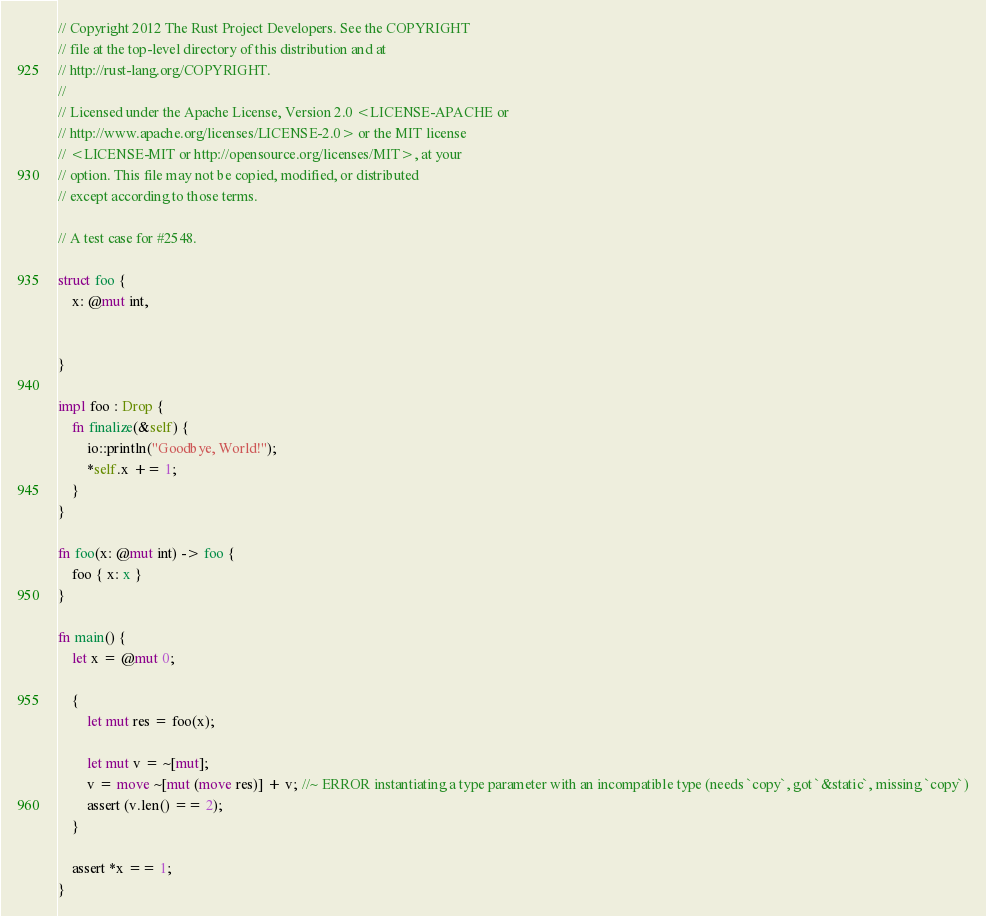<code> <loc_0><loc_0><loc_500><loc_500><_Rust_>// Copyright 2012 The Rust Project Developers. See the COPYRIGHT
// file at the top-level directory of this distribution and at
// http://rust-lang.org/COPYRIGHT.
//
// Licensed under the Apache License, Version 2.0 <LICENSE-APACHE or
// http://www.apache.org/licenses/LICENSE-2.0> or the MIT license
// <LICENSE-MIT or http://opensource.org/licenses/MIT>, at your
// option. This file may not be copied, modified, or distributed
// except according to those terms.

// A test case for #2548.

struct foo {
    x: @mut int,


}

impl foo : Drop {
    fn finalize(&self) {
        io::println("Goodbye, World!");
        *self.x += 1;
    }
}

fn foo(x: @mut int) -> foo {
    foo { x: x }
}

fn main() {
    let x = @mut 0;

    {
        let mut res = foo(x);

        let mut v = ~[mut];
        v = move ~[mut (move res)] + v; //~ ERROR instantiating a type parameter with an incompatible type (needs `copy`, got `&static`, missing `copy`)
        assert (v.len() == 2);
    }

    assert *x == 1;
}
</code> 